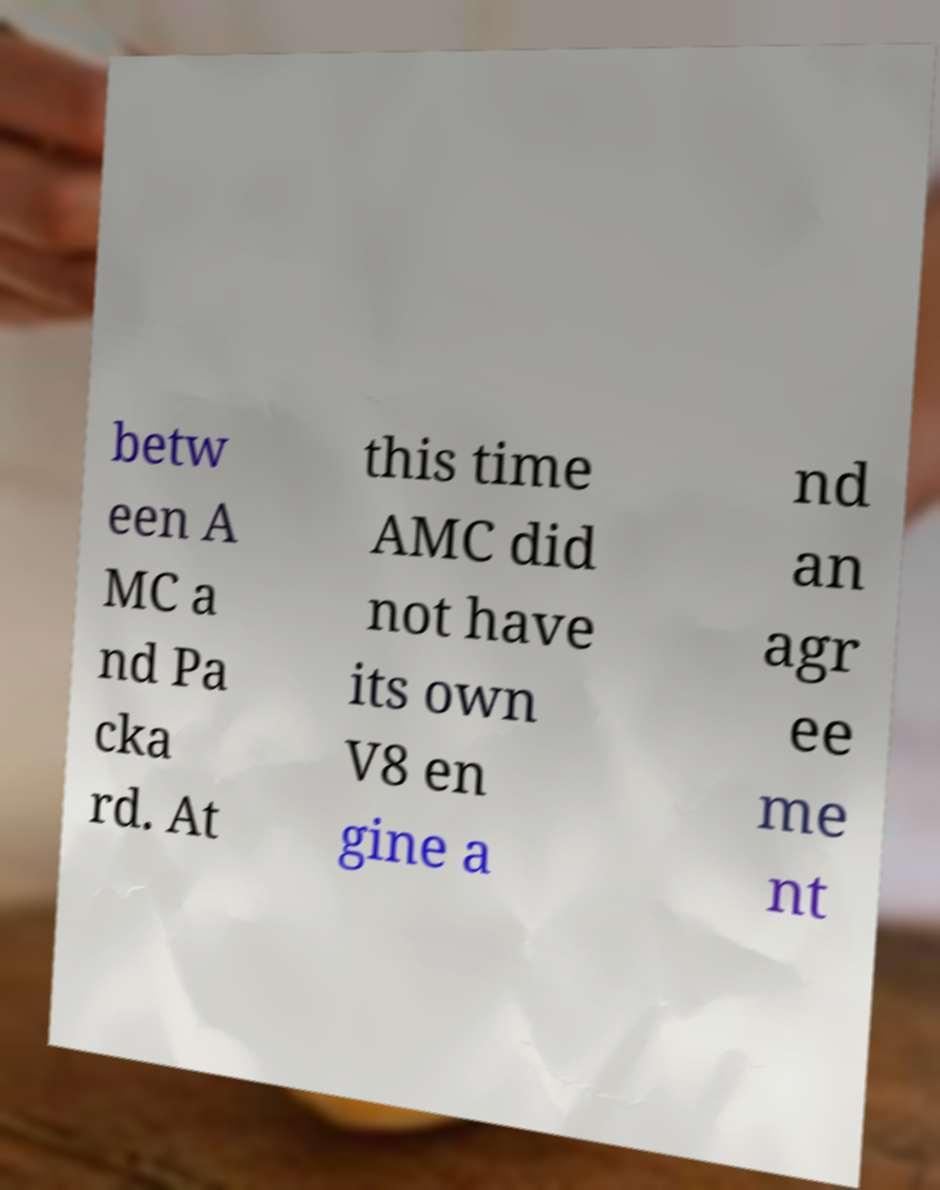Can you accurately transcribe the text from the provided image for me? betw een A MC a nd Pa cka rd. At this time AMC did not have its own V8 en gine a nd an agr ee me nt 